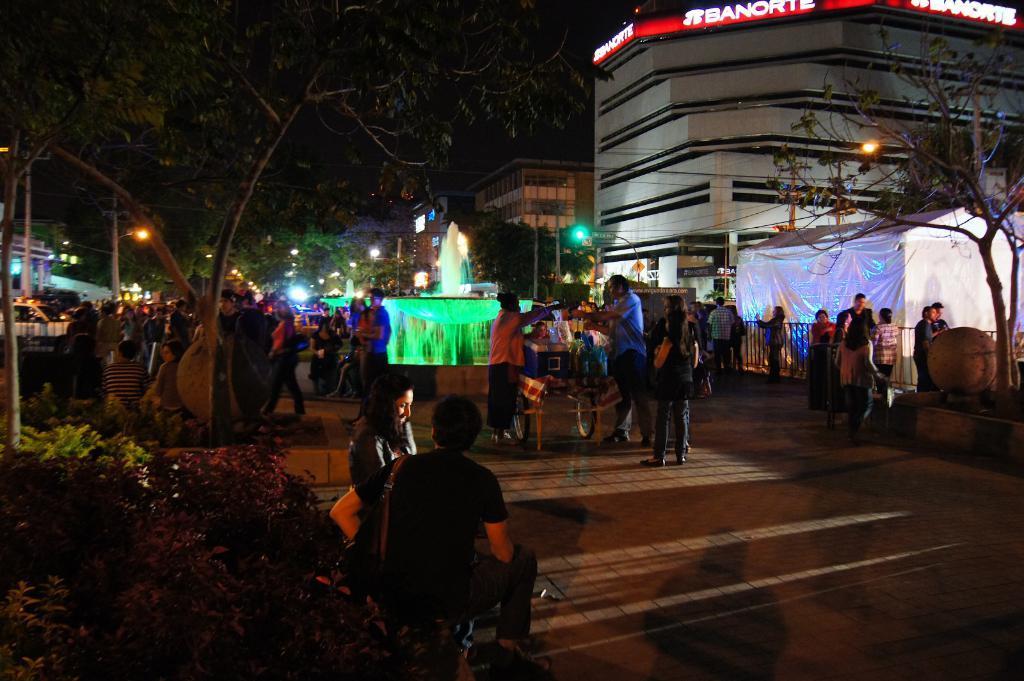In one or two sentences, can you explain what this image depicts? This picture is clicked outside. In the center we can see the group of persons. On the left we can see the plants and there are many number of objects placed on the ground and we can see a fountain, lights, poles, trees, buildings and a white color tent. In the background there is a sky and we can see the text on the building. 